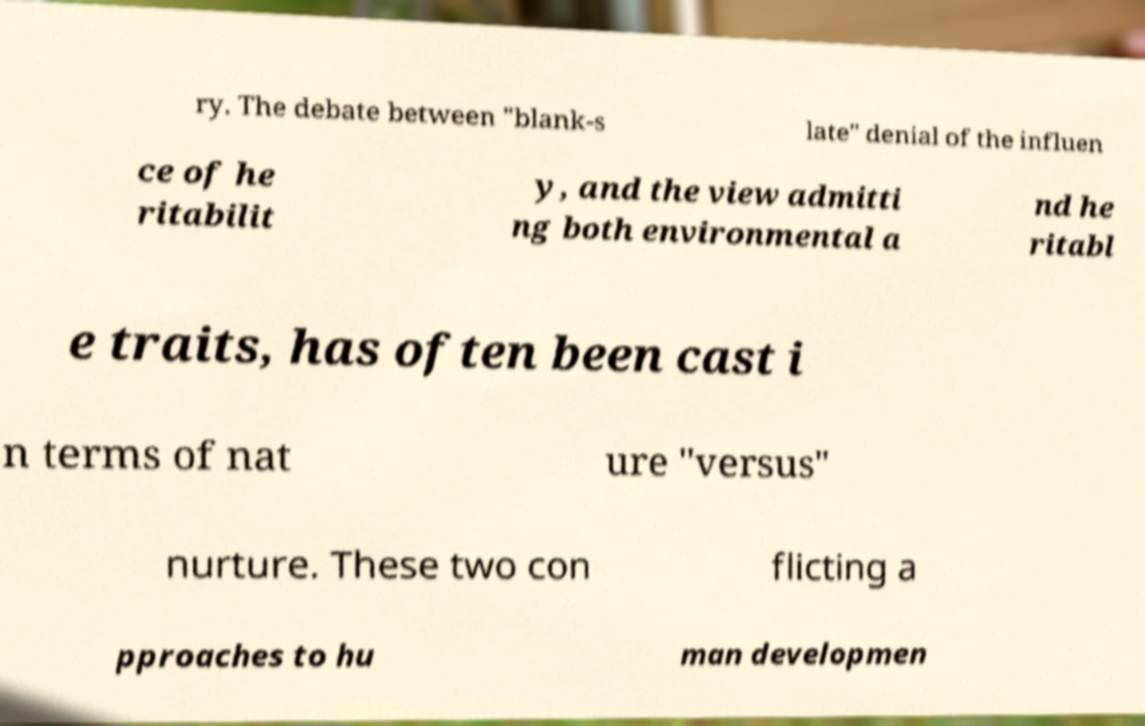Can you accurately transcribe the text from the provided image for me? ry. The debate between "blank-s late" denial of the influen ce of he ritabilit y, and the view admitti ng both environmental a nd he ritabl e traits, has often been cast i n terms of nat ure "versus" nurture. These two con flicting a pproaches to hu man developmen 